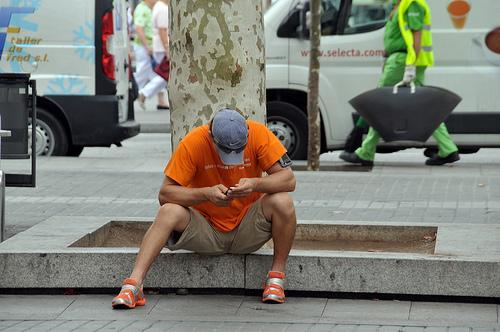What device is the one most probably attached to the man's arm? Please explain your reasoning. music player. There is a man with a mp3 or something with headphones. 